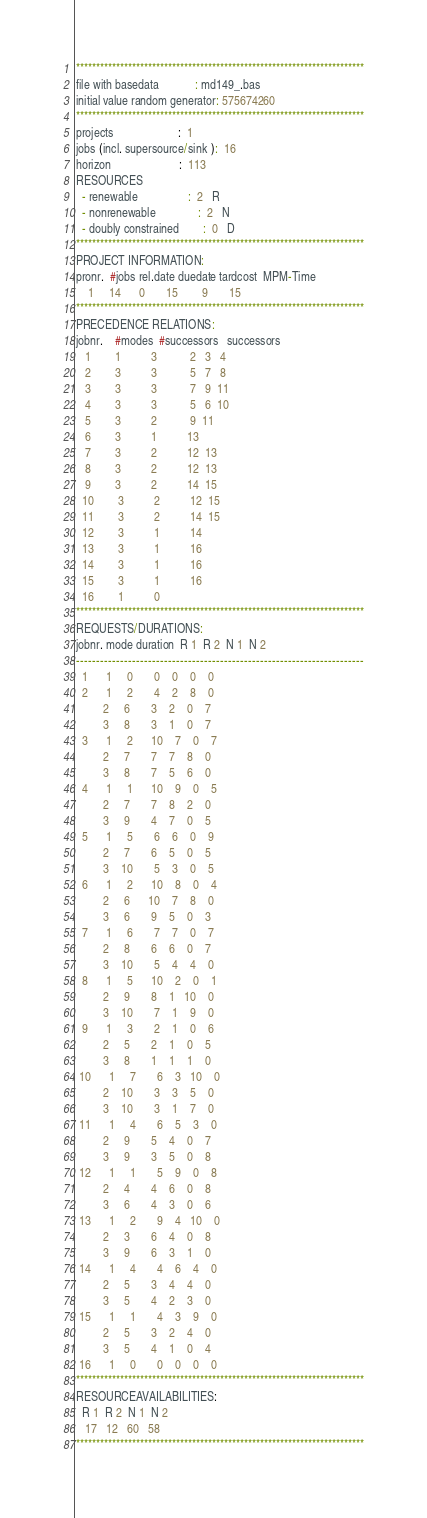Convert code to text. <code><loc_0><loc_0><loc_500><loc_500><_ObjectiveC_>************************************************************************
file with basedata            : md149_.bas
initial value random generator: 575674260
************************************************************************
projects                      :  1
jobs (incl. supersource/sink ):  16
horizon                       :  113
RESOURCES
  - renewable                 :  2   R
  - nonrenewable              :  2   N
  - doubly constrained        :  0   D
************************************************************************
PROJECT INFORMATION:
pronr.  #jobs rel.date duedate tardcost  MPM-Time
    1     14      0       15        9       15
************************************************************************
PRECEDENCE RELATIONS:
jobnr.    #modes  #successors   successors
   1        1          3           2   3   4
   2        3          3           5   7   8
   3        3          3           7   9  11
   4        3          3           5   6  10
   5        3          2           9  11
   6        3          1          13
   7        3          2          12  13
   8        3          2          12  13
   9        3          2          14  15
  10        3          2          12  15
  11        3          2          14  15
  12        3          1          14
  13        3          1          16
  14        3          1          16
  15        3          1          16
  16        1          0        
************************************************************************
REQUESTS/DURATIONS:
jobnr. mode duration  R 1  R 2  N 1  N 2
------------------------------------------------------------------------
  1      1     0       0    0    0    0
  2      1     2       4    2    8    0
         2     6       3    2    0    7
         3     8       3    1    0    7
  3      1     2      10    7    0    7
         2     7       7    7    8    0
         3     8       7    5    6    0
  4      1     1      10    9    0    5
         2     7       7    8    2    0
         3     9       4    7    0    5
  5      1     5       6    6    0    9
         2     7       6    5    0    5
         3    10       5    3    0    5
  6      1     2      10    8    0    4
         2     6      10    7    8    0
         3     6       9    5    0    3
  7      1     6       7    7    0    7
         2     8       6    6    0    7
         3    10       5    4    4    0
  8      1     5      10    2    0    1
         2     9       8    1   10    0
         3    10       7    1    9    0
  9      1     3       2    1    0    6
         2     5       2    1    0    5
         3     8       1    1    1    0
 10      1     7       6    3   10    0
         2    10       3    3    5    0
         3    10       3    1    7    0
 11      1     4       6    5    3    0
         2     9       5    4    0    7
         3     9       3    5    0    8
 12      1     1       5    9    0    8
         2     4       4    6    0    8
         3     6       4    3    0    6
 13      1     2       9    4   10    0
         2     3       6    4    0    8
         3     9       6    3    1    0
 14      1     4       4    6    4    0
         2     5       3    4    4    0
         3     5       4    2    3    0
 15      1     1       4    3    9    0
         2     5       3    2    4    0
         3     5       4    1    0    4
 16      1     0       0    0    0    0
************************************************************************
RESOURCEAVAILABILITIES:
  R 1  R 2  N 1  N 2
   17   12   60   58
************************************************************************
</code> 